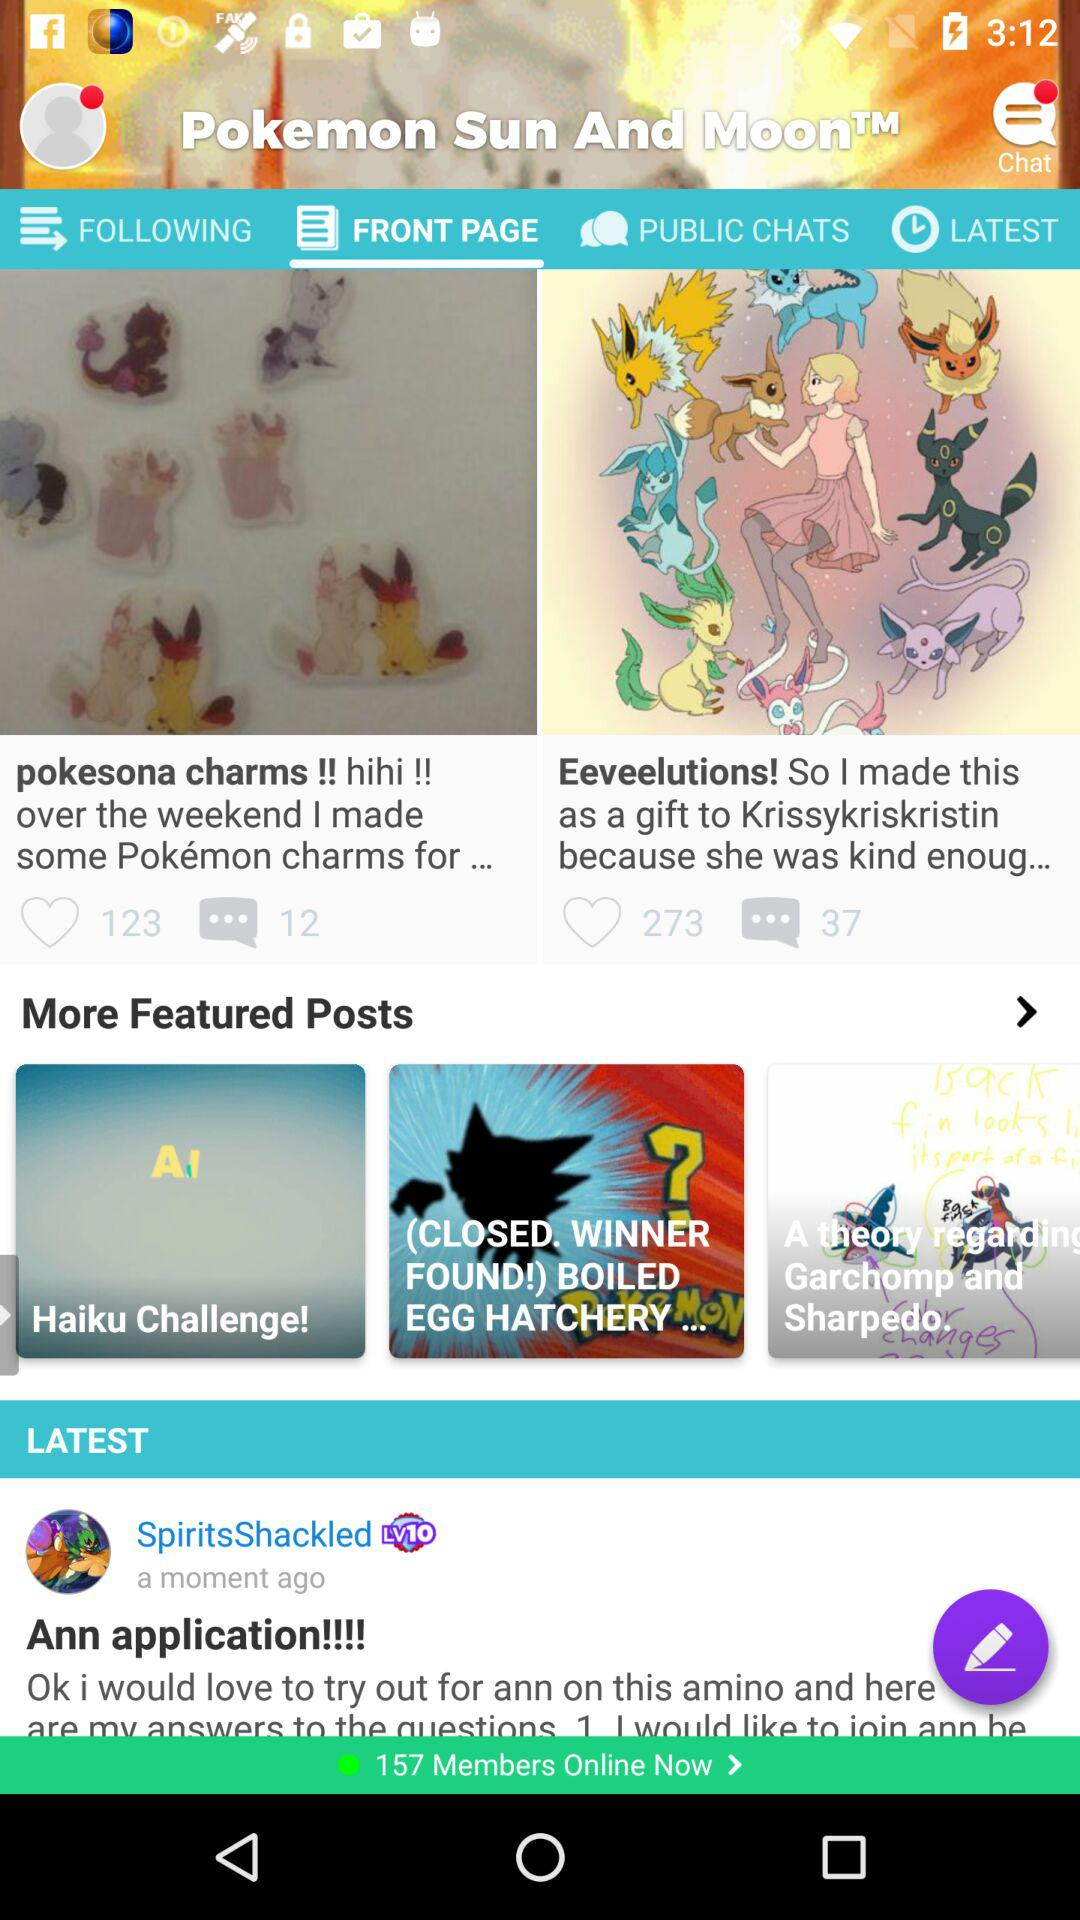How many more featured posts are there than latest posts?
Answer the question using a single word or phrase. 2 